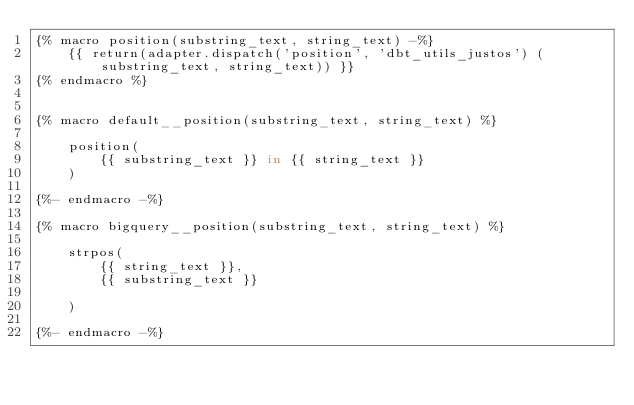<code> <loc_0><loc_0><loc_500><loc_500><_SQL_>{% macro position(substring_text, string_text) -%}
    {{ return(adapter.dispatch('position', 'dbt_utils_justos') (substring_text, string_text)) }}
{% endmacro %}


{% macro default__position(substring_text, string_text) %}

    position(
        {{ substring_text }} in {{ string_text }}
    )
    
{%- endmacro -%}

{% macro bigquery__position(substring_text, string_text) %}

    strpos(
        {{ string_text }},
        {{ substring_text }}
        
    )
    
{%- endmacro -%}
</code> 